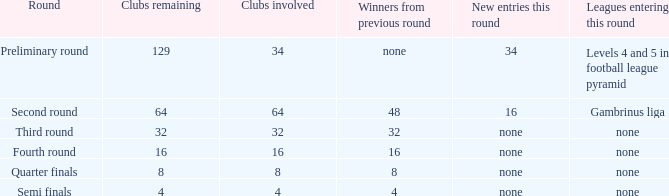Name the leagues entering this round for 4 None. 